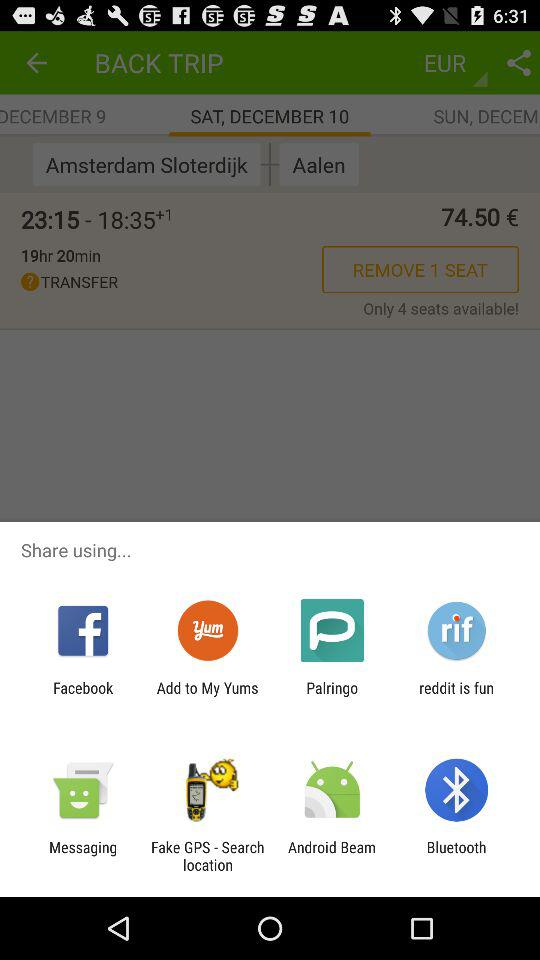How many seats are available?
Answer the question using a single word or phrase. 4 